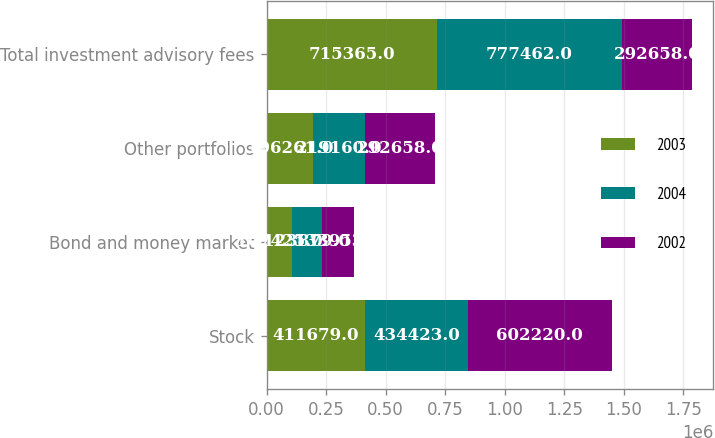Convert chart to OTSL. <chart><loc_0><loc_0><loc_500><loc_500><stacked_bar_chart><ecel><fcel>Stock<fcel>Bond and money market<fcel>Other portfolios<fcel>Total investment advisory fees<nl><fcel>2003<fcel>411679<fcel>107425<fcel>196261<fcel>715365<nl><fcel>2004<fcel>434423<fcel>123879<fcel>219160<fcel>777462<nl><fcel>2002<fcel>602220<fcel>133953<fcel>292658<fcel>292658<nl></chart> 